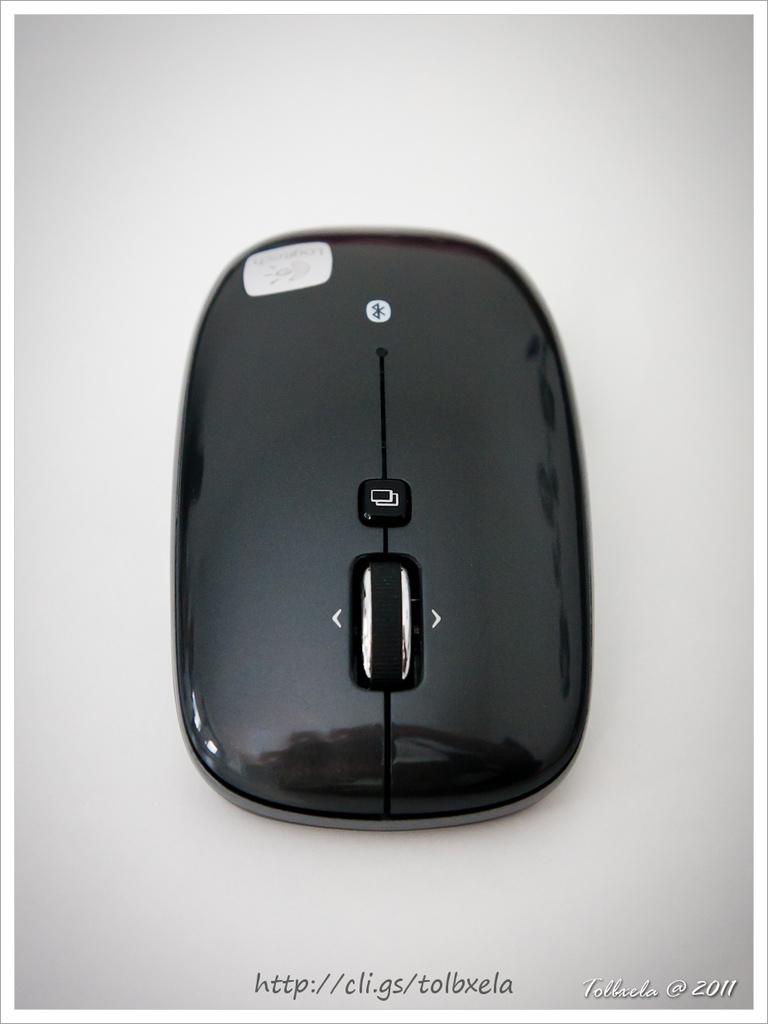What url is listed here?
Provide a short and direct response. Http://cli.gs/tolbxela. 